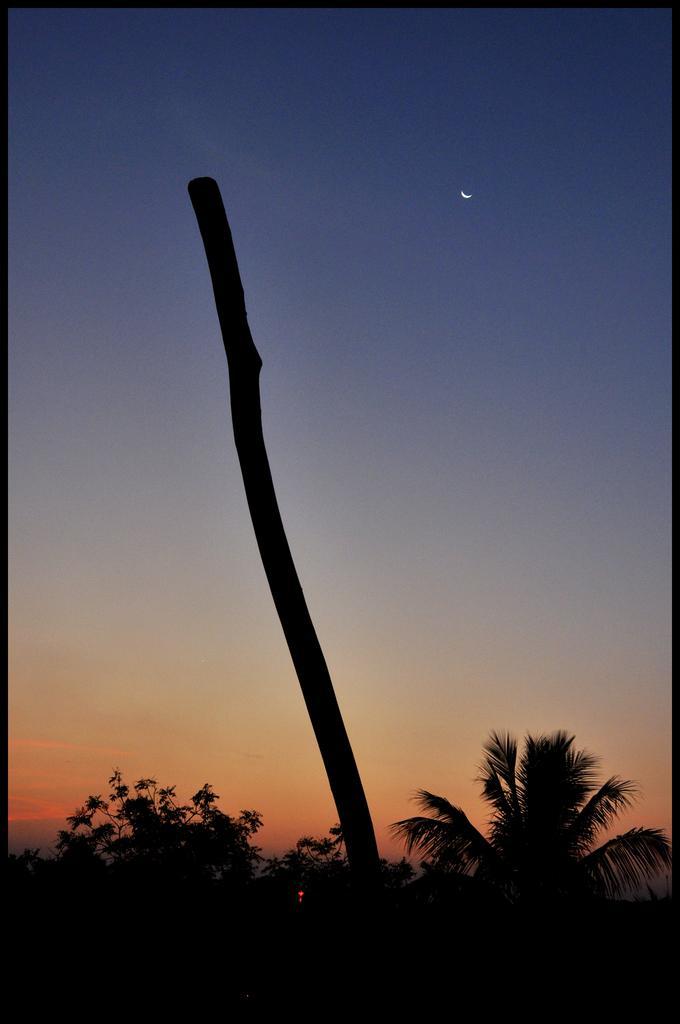How would you summarize this image in a sentence or two? In this image, we can see a pole. At the bottom, we can see trees. Background there is the sky and half moon. We can see black color borders on this image. 